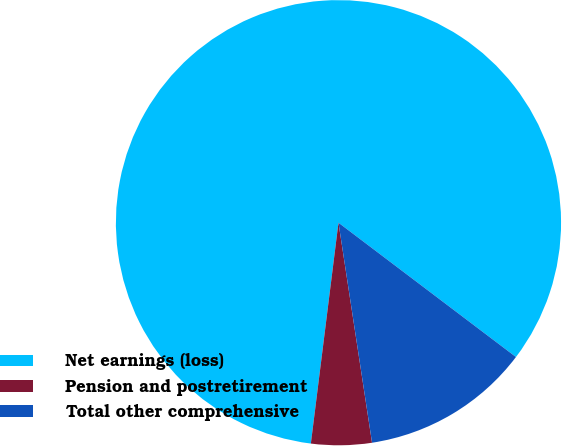Convert chart to OTSL. <chart><loc_0><loc_0><loc_500><loc_500><pie_chart><fcel>Net earnings (loss)<fcel>Pension and postretirement<fcel>Total other comprehensive<nl><fcel>83.33%<fcel>4.39%<fcel>12.28%<nl></chart> 